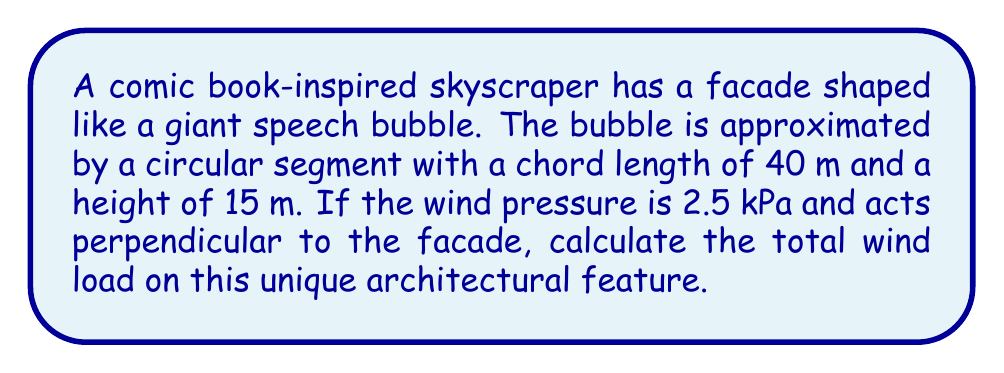Can you answer this question? To solve this problem, we'll follow these steps:

1. Calculate the radius of the circular segment:
   The formula for the radius (R) of a circular segment is:
   $$R = \frac{h}{2} + \frac{c^2}{8h}$$
   where h is the height and c is the chord length.

   $$R = \frac{15}{2} + \frac{40^2}{8(15)} = 7.5 + 133.33 = 140.83 \text{ m}$$

2. Calculate the area of the circular segment:
   The formula for the area (A) of a circular segment is:
   $$A = R^2 \arccos\left(\frac{R-h}{R}\right) - (R-h)\sqrt{2Rh-h^2}$$

   Substituting the values:
   $$A = 140.83^2 \arccos\left(\frac{140.83-15}{140.83}\right) - (140.83-15)\sqrt{2(140.83)(15)-15^2}$$
   $$A = 19833.08 \arccos(0.8935) - 125.83\sqrt{4224.9-225}$$
   $$A = 19833.08 (0.4636) - 125.83 (63.87)$$
   $$A = 9196.62 - 8037.25 = 1159.37 \text{ m}^2$$

3. Calculate the wind load:
   Wind load = Pressure × Area
   $$F = 2.5 \text{ kPa} \times 1159.37 \text{ m}^2 = 2898.43 \text{ kN}$$

[asy]
import geometry;

size(200);
pair O = (0,0);
real R = 140.83;
real h = 15;
real c = 40;

path bubble = arc((0,R-h), R, 180-acos((R-h)/R)*180/pi, 180+acos((R-h)/R)*180/pi);
draw(bubble);
draw((-c/2,0)--(c/2,0));
draw((0,0)--(0,h));

label("15 m", (c/2+1,h/2), E);
label("40 m", (0,-1), S);

[/asy]
Answer: 2898.43 kN 